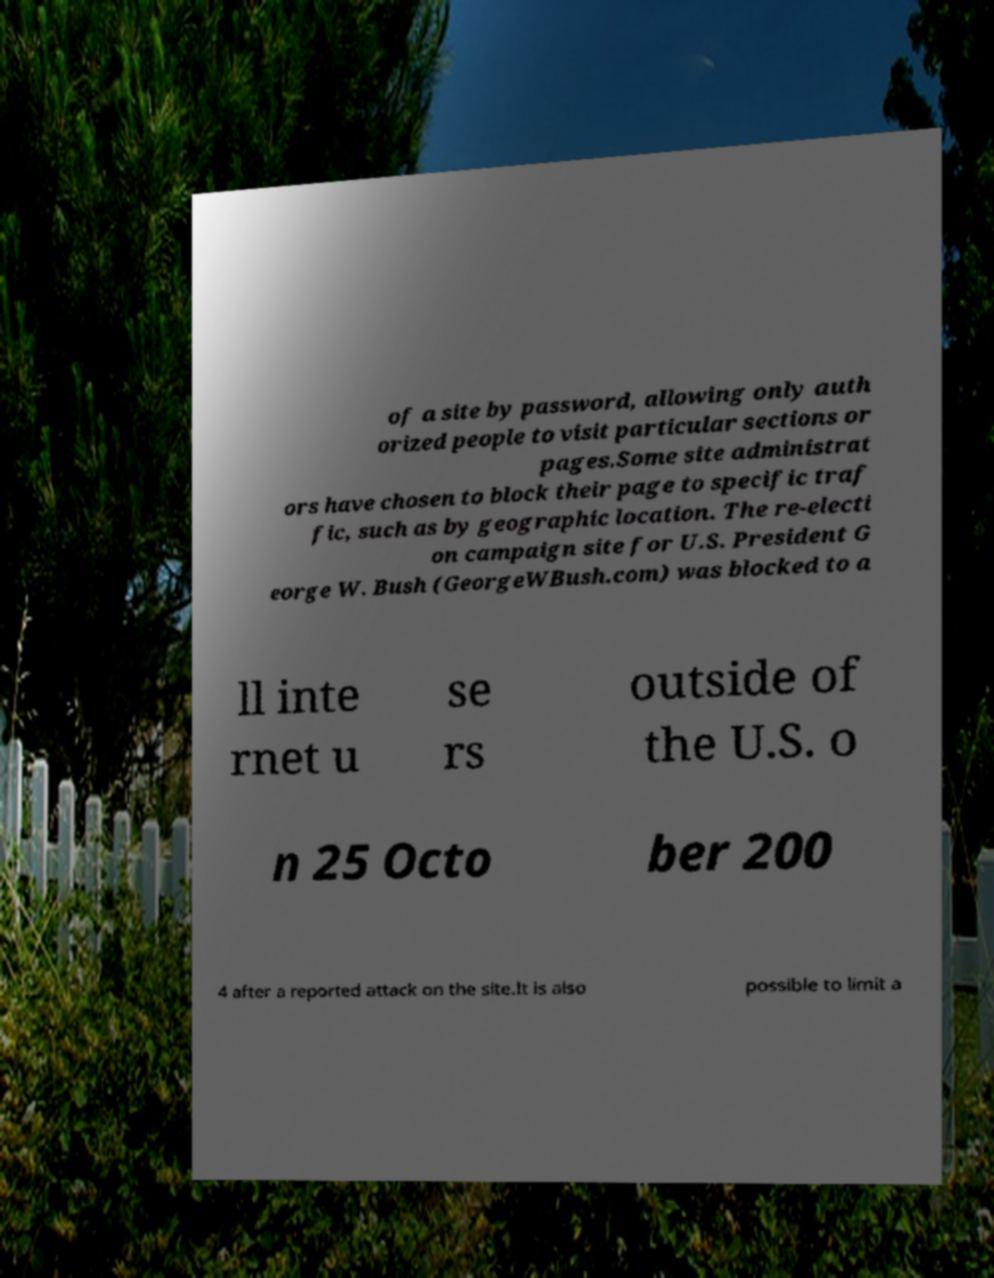Could you extract and type out the text from this image? of a site by password, allowing only auth orized people to visit particular sections or pages.Some site administrat ors have chosen to block their page to specific traf fic, such as by geographic location. The re-electi on campaign site for U.S. President G eorge W. Bush (GeorgeWBush.com) was blocked to a ll inte rnet u se rs outside of the U.S. o n 25 Octo ber 200 4 after a reported attack on the site.It is also possible to limit a 